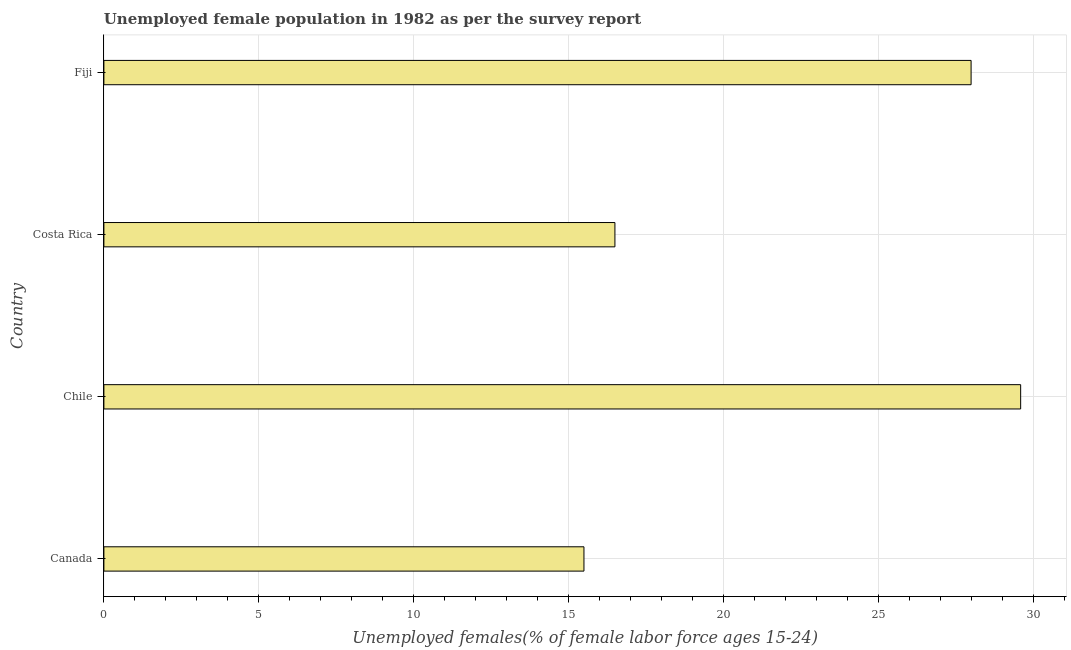Does the graph contain grids?
Your response must be concise. Yes. What is the title of the graph?
Offer a very short reply. Unemployed female population in 1982 as per the survey report. What is the label or title of the X-axis?
Keep it short and to the point. Unemployed females(% of female labor force ages 15-24). What is the unemployed female youth in Chile?
Your answer should be very brief. 29.6. Across all countries, what is the maximum unemployed female youth?
Ensure brevity in your answer.  29.6. In which country was the unemployed female youth minimum?
Your answer should be compact. Canada. What is the sum of the unemployed female youth?
Make the answer very short. 89.6. What is the difference between the unemployed female youth in Chile and Costa Rica?
Your answer should be compact. 13.1. What is the average unemployed female youth per country?
Give a very brief answer. 22.4. What is the median unemployed female youth?
Provide a succinct answer. 22.25. In how many countries, is the unemployed female youth greater than 29 %?
Your answer should be compact. 1. What is the ratio of the unemployed female youth in Canada to that in Costa Rica?
Provide a succinct answer. 0.94. Is the unemployed female youth in Costa Rica less than that in Fiji?
Ensure brevity in your answer.  Yes. Is the difference between the unemployed female youth in Canada and Costa Rica greater than the difference between any two countries?
Keep it short and to the point. No. What is the difference between the highest and the second highest unemployed female youth?
Your response must be concise. 1.6. Is the sum of the unemployed female youth in Chile and Costa Rica greater than the maximum unemployed female youth across all countries?
Provide a succinct answer. Yes. In how many countries, is the unemployed female youth greater than the average unemployed female youth taken over all countries?
Keep it short and to the point. 2. What is the Unemployed females(% of female labor force ages 15-24) of Chile?
Your answer should be compact. 29.6. What is the Unemployed females(% of female labor force ages 15-24) in Costa Rica?
Provide a short and direct response. 16.5. What is the difference between the Unemployed females(% of female labor force ages 15-24) in Canada and Chile?
Offer a terse response. -14.1. What is the difference between the Unemployed females(% of female labor force ages 15-24) in Canada and Costa Rica?
Give a very brief answer. -1. What is the difference between the Unemployed females(% of female labor force ages 15-24) in Canada and Fiji?
Offer a terse response. -12.5. What is the difference between the Unemployed females(% of female labor force ages 15-24) in Chile and Costa Rica?
Provide a succinct answer. 13.1. What is the ratio of the Unemployed females(% of female labor force ages 15-24) in Canada to that in Chile?
Your answer should be very brief. 0.52. What is the ratio of the Unemployed females(% of female labor force ages 15-24) in Canada to that in Costa Rica?
Your answer should be very brief. 0.94. What is the ratio of the Unemployed females(% of female labor force ages 15-24) in Canada to that in Fiji?
Offer a very short reply. 0.55. What is the ratio of the Unemployed females(% of female labor force ages 15-24) in Chile to that in Costa Rica?
Your response must be concise. 1.79. What is the ratio of the Unemployed females(% of female labor force ages 15-24) in Chile to that in Fiji?
Keep it short and to the point. 1.06. What is the ratio of the Unemployed females(% of female labor force ages 15-24) in Costa Rica to that in Fiji?
Offer a very short reply. 0.59. 